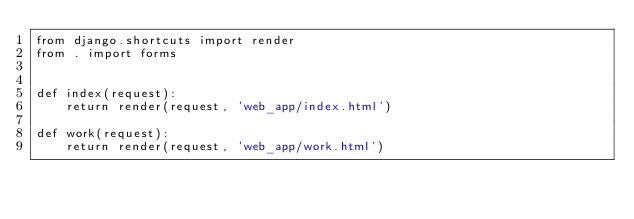Convert code to text. <code><loc_0><loc_0><loc_500><loc_500><_Python_>from django.shortcuts import render
from . import forms


def index(request):
    return render(request, 'web_app/index.html')

def work(request):
    return render(request, 'web_app/work.html')
</code> 